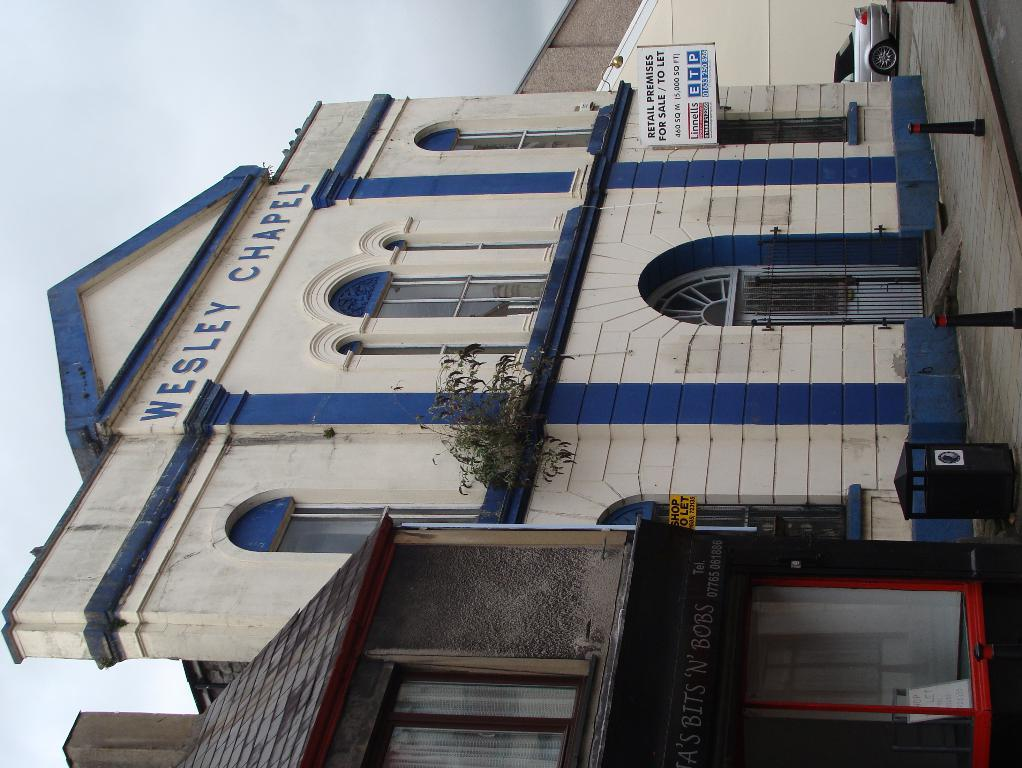What type of structure is present in the image? There is a building in the image. What is attached to or near the building? There is a board associated with the building. What else can be seen near the building? There is a vehicle to the side of the building. What can be seen in the distance behind the building? The sky is visible in the background of the image. What type of crime is being committed in the image? There is no indication of any crime being committed in the image. The image features a building, a board, a vehicle, and the sky. 